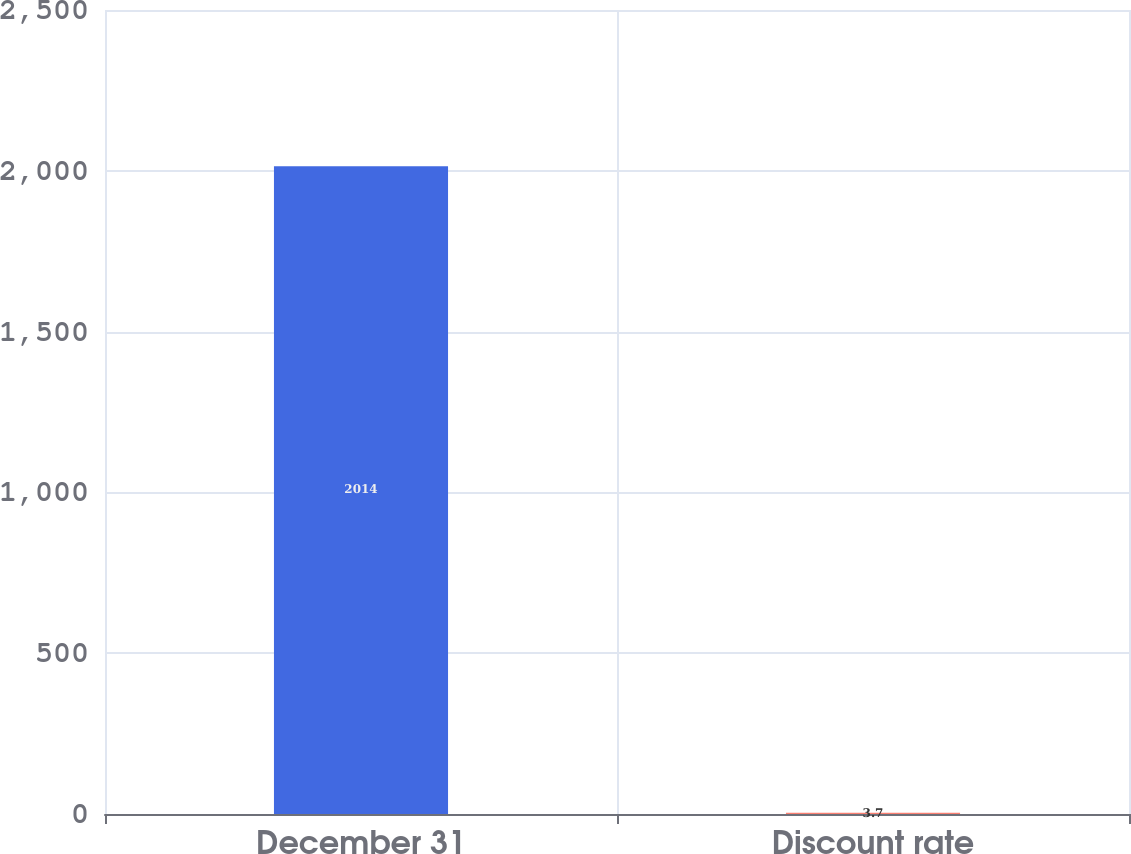Convert chart. <chart><loc_0><loc_0><loc_500><loc_500><bar_chart><fcel>December 31<fcel>Discount rate<nl><fcel>2014<fcel>3.7<nl></chart> 